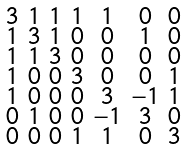Convert formula to latex. <formula><loc_0><loc_0><loc_500><loc_500>\begin{smallmatrix} 3 & 1 & 1 & 1 & 1 & 0 & 0 \\ 1 & 3 & 1 & 0 & 0 & 1 & 0 \\ 1 & 1 & 3 & 0 & 0 & 0 & 0 \\ 1 & 0 & 0 & 3 & 0 & 0 & 1 \\ 1 & 0 & 0 & 0 & 3 & - 1 & 1 \\ 0 & 1 & 0 & 0 & - 1 & 3 & 0 \\ 0 & 0 & 0 & 1 & 1 & 0 & 3 \end{smallmatrix}</formula> 